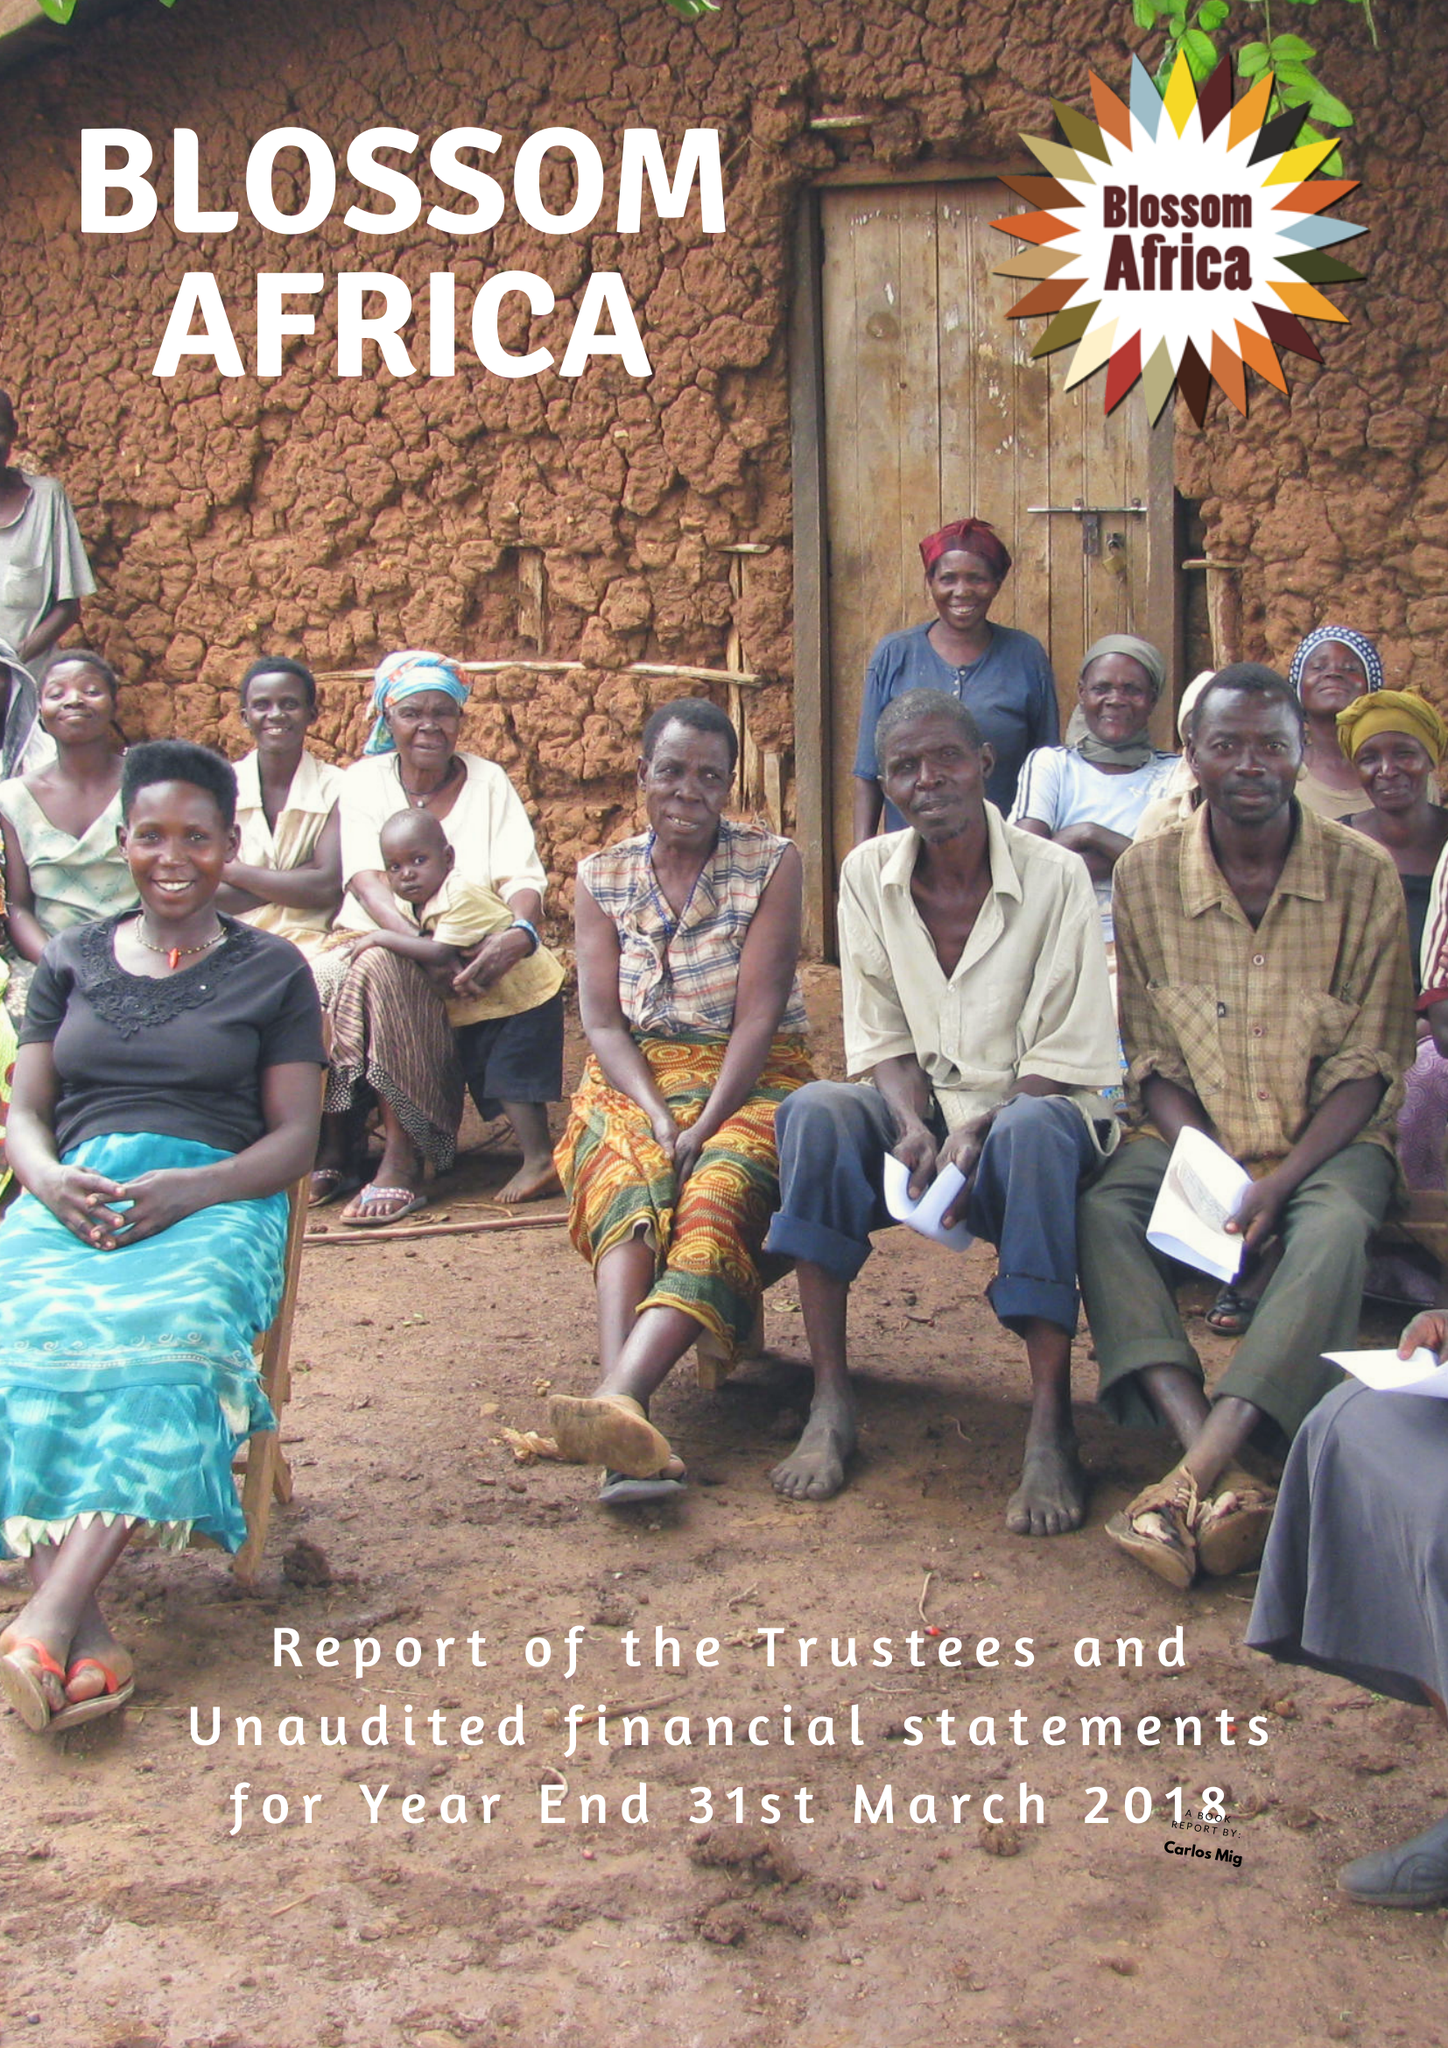What is the value for the address__postcode?
Answer the question using a single word or phrase. NP18 1NJ 